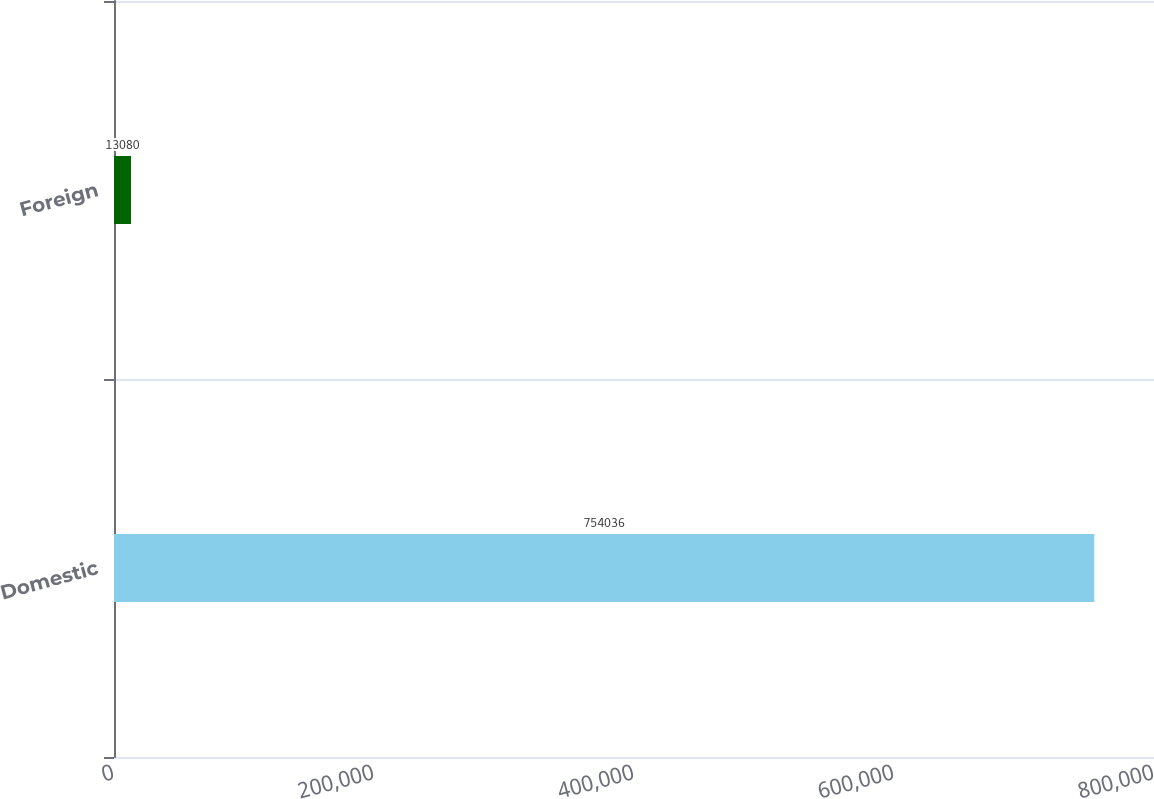Convert chart. <chart><loc_0><loc_0><loc_500><loc_500><bar_chart><fcel>Domestic<fcel>Foreign<nl><fcel>754036<fcel>13080<nl></chart> 